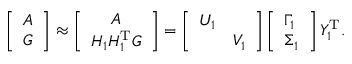Convert formula to latex. <formula><loc_0><loc_0><loc_500><loc_500>\left [ \begin{array} { l } { A } \\ { G } \end{array} \right ] \approx \left [ \begin{array} { c } { A } \\ { H _ { 1 } H _ { 1 } ^ { T } G } \end{array} \right ] = \left [ \begin{array} { l l } { U _ { 1 } } & \\ & { V _ { 1 } } \end{array} \right ] \left [ \begin{array} { l } { \Gamma _ { 1 } } \\ { \Sigma _ { 1 } } \end{array} \right ] Y _ { 1 } ^ { T } .</formula> 